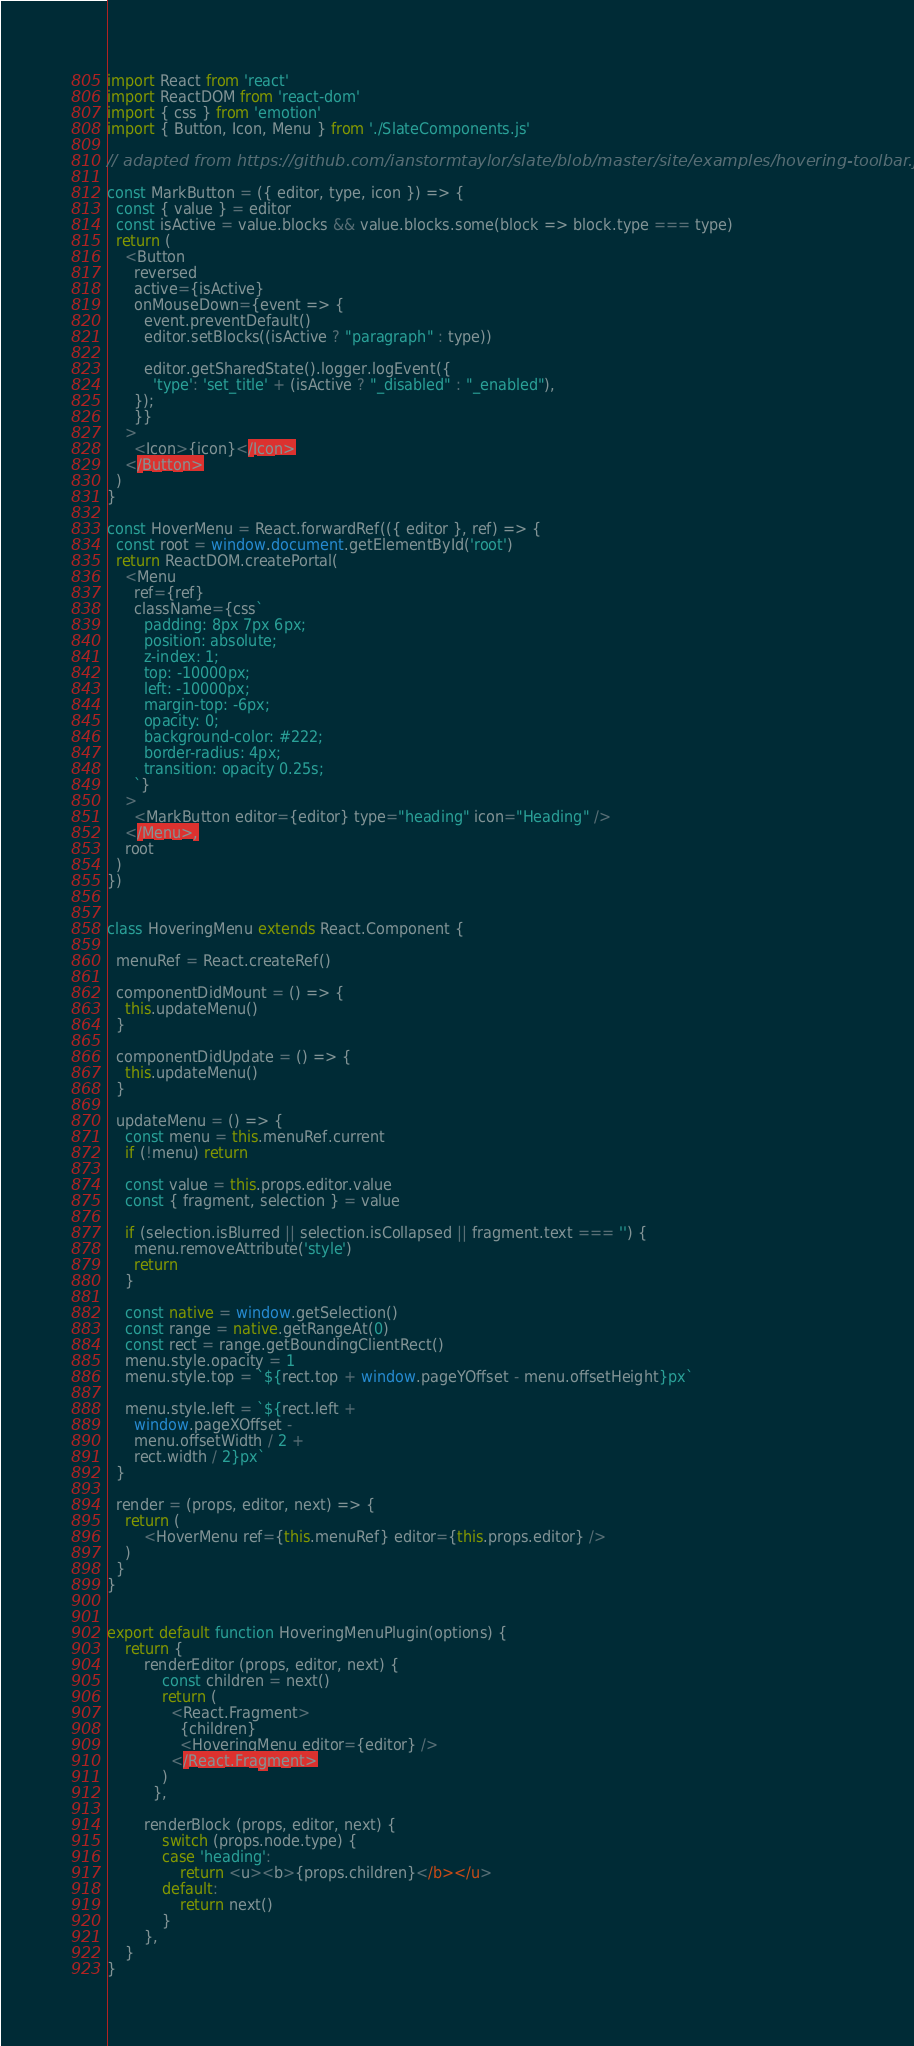Convert code to text. <code><loc_0><loc_0><loc_500><loc_500><_JavaScript_>import React from 'react'
import ReactDOM from 'react-dom'
import { css } from 'emotion'
import { Button, Icon, Menu } from './SlateComponents.js'

// adapted from https://github.com/ianstormtaylor/slate/blob/master/site/examples/hovering-toolbar.js

const MarkButton = ({ editor, type, icon }) => {
  const { value } = editor
  const isActive = value.blocks && value.blocks.some(block => block.type === type)
  return (
    <Button
      reversed
      active={isActive}
      onMouseDown={event => {
        event.preventDefault()
        editor.setBlocks((isActive ? "paragraph" : type))

        editor.getSharedState().logger.logEvent({
          'type': 'set_title' + (isActive ? "_disabled" : "_enabled"),
      });
      }}
    >
      <Icon>{icon}</Icon>
    </Button>
  )
}

const HoverMenu = React.forwardRef(({ editor }, ref) => {
  const root = window.document.getElementById('root')
  return ReactDOM.createPortal(
    <Menu
      ref={ref}
      className={css`
        padding: 8px 7px 6px;
        position: absolute;
        z-index: 1;
        top: -10000px;
        left: -10000px;
        margin-top: -6px;
        opacity: 0;
        background-color: #222;
        border-radius: 4px;
        transition: opacity 0.25s;
      `}
    >
      <MarkButton editor={editor} type="heading" icon="Heading" />
    </Menu>,
    root
  )
})


class HoveringMenu extends React.Component {

  menuRef = React.createRef()

  componentDidMount = () => {
    this.updateMenu()
  }

  componentDidUpdate = () => {
    this.updateMenu()
  }

  updateMenu = () => {
    const menu = this.menuRef.current
    if (!menu) return

    const value = this.props.editor.value
    const { fragment, selection } = value

    if (selection.isBlurred || selection.isCollapsed || fragment.text === '') {
      menu.removeAttribute('style')
      return
    }

    const native = window.getSelection()
    const range = native.getRangeAt(0)
    const rect = range.getBoundingClientRect()
    menu.style.opacity = 1
    menu.style.top = `${rect.top + window.pageYOffset - menu.offsetHeight}px`

    menu.style.left = `${rect.left +
      window.pageXOffset -
      menu.offsetWidth / 2 +
      rect.width / 2}px`
  }

  render = (props, editor, next) => {
    return (
        <HoverMenu ref={this.menuRef} editor={this.props.editor} />
    )
  }
}


export default function HoveringMenuPlugin(options) {
    return {
        renderEditor (props, editor, next) {
            const children = next()
            return (
              <React.Fragment>
                {children}
                <HoveringMenu editor={editor} />
              </React.Fragment>
            )
          },

        renderBlock (props, editor, next) {
            switch (props.node.type) {
            case 'heading':
                return <u><b>{props.children}</b></u>
            default:
                return next()
            }
        },
    }
}</code> 